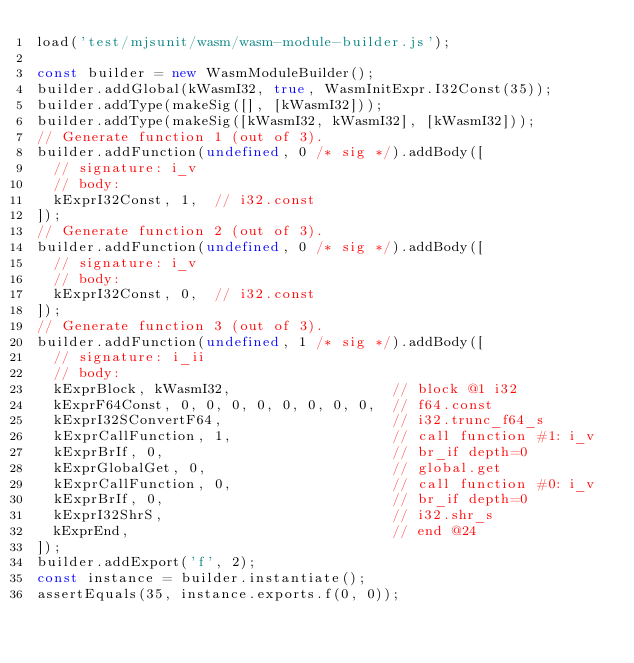Convert code to text. <code><loc_0><loc_0><loc_500><loc_500><_JavaScript_>load('test/mjsunit/wasm/wasm-module-builder.js');

const builder = new WasmModuleBuilder();
builder.addGlobal(kWasmI32, true, WasmInitExpr.I32Const(35));
builder.addType(makeSig([], [kWasmI32]));
builder.addType(makeSig([kWasmI32, kWasmI32], [kWasmI32]));
// Generate function 1 (out of 3).
builder.addFunction(undefined, 0 /* sig */).addBody([
  // signature: i_v
  // body:
  kExprI32Const, 1,  // i32.const
]);
// Generate function 2 (out of 3).
builder.addFunction(undefined, 0 /* sig */).addBody([
  // signature: i_v
  // body:
  kExprI32Const, 0,  // i32.const
]);
// Generate function 3 (out of 3).
builder.addFunction(undefined, 1 /* sig */).addBody([
  // signature: i_ii
  // body:
  kExprBlock, kWasmI32,                   // block @1 i32
  kExprF64Const, 0, 0, 0, 0, 0, 0, 0, 0,  // f64.const
  kExprI32SConvertF64,                    // i32.trunc_f64_s
  kExprCallFunction, 1,                   // call function #1: i_v
  kExprBrIf, 0,                           // br_if depth=0
  kExprGlobalGet, 0,                      // global.get
  kExprCallFunction, 0,                   // call function #0: i_v
  kExprBrIf, 0,                           // br_if depth=0
  kExprI32ShrS,                           // i32.shr_s
  kExprEnd,                               // end @24
]);
builder.addExport('f', 2);
const instance = builder.instantiate();
assertEquals(35, instance.exports.f(0, 0));
</code> 